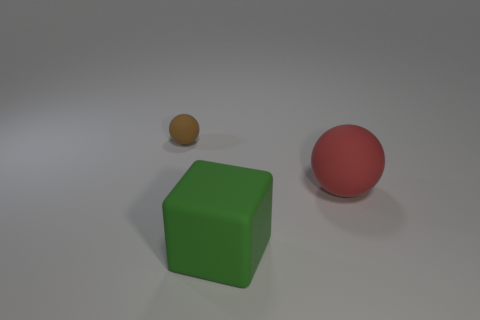Can you describe the surface the objects are resting on? The surface appears to be smooth and flat, with a matte finish that diffuses the light evenly, giving it a soft, uniform appearance. It resembles a typical studio backdrop for product photography. 